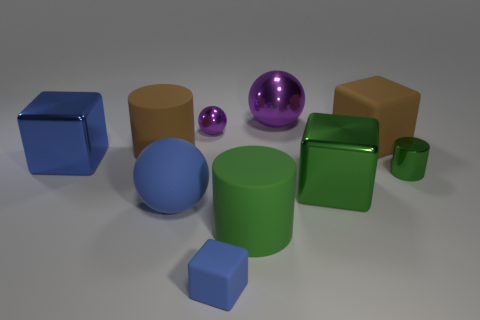Subtract 2 cubes. How many cubes are left? 2 Subtract all cubes. How many objects are left? 6 Add 8 yellow matte things. How many yellow matte things exist? 8 Subtract 1 blue cubes. How many objects are left? 9 Subtract all blue things. Subtract all blue matte objects. How many objects are left? 5 Add 5 tiny purple metal things. How many tiny purple metal things are left? 6 